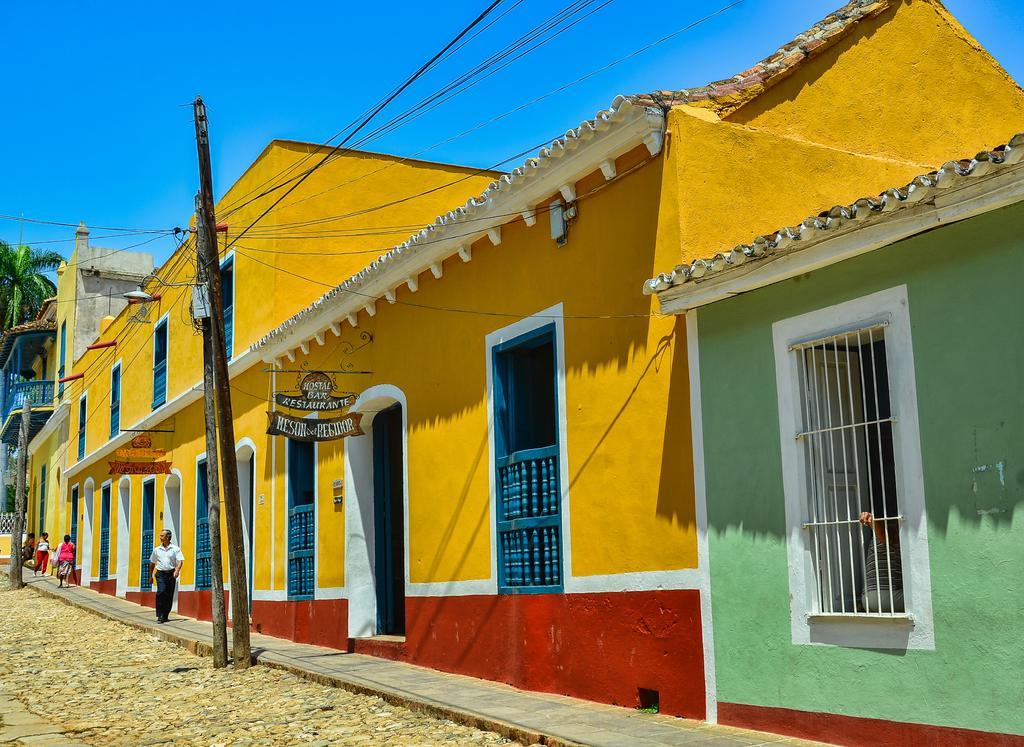In one or two sentences, can you explain what this image depicts? In this picture I can see few persons standing. There are buildings, poles, cables, boards, tree, and in the background there is the sky. 